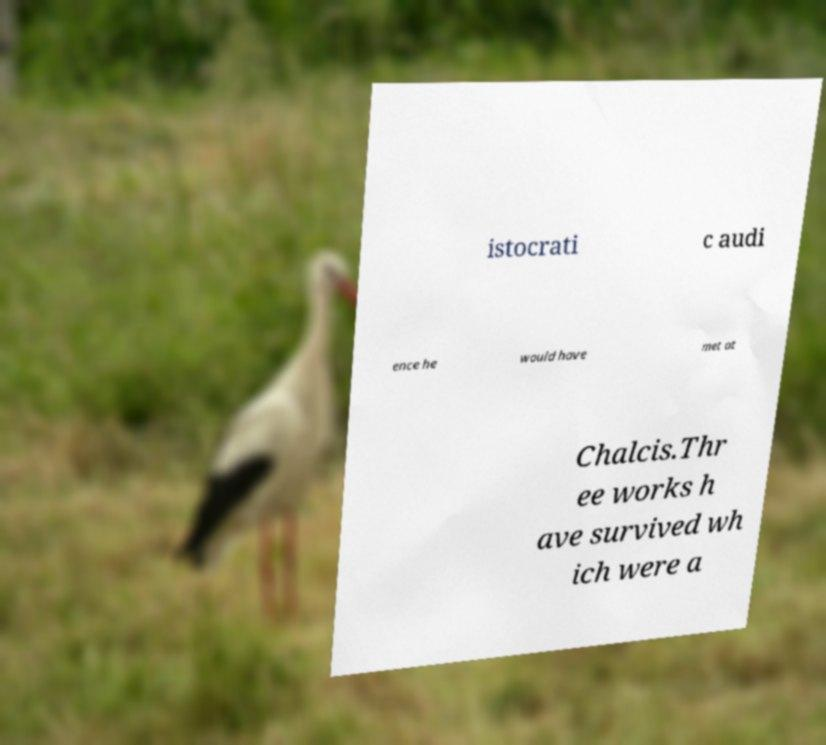Can you read and provide the text displayed in the image?This photo seems to have some interesting text. Can you extract and type it out for me? istocrati c audi ence he would have met at Chalcis.Thr ee works h ave survived wh ich were a 